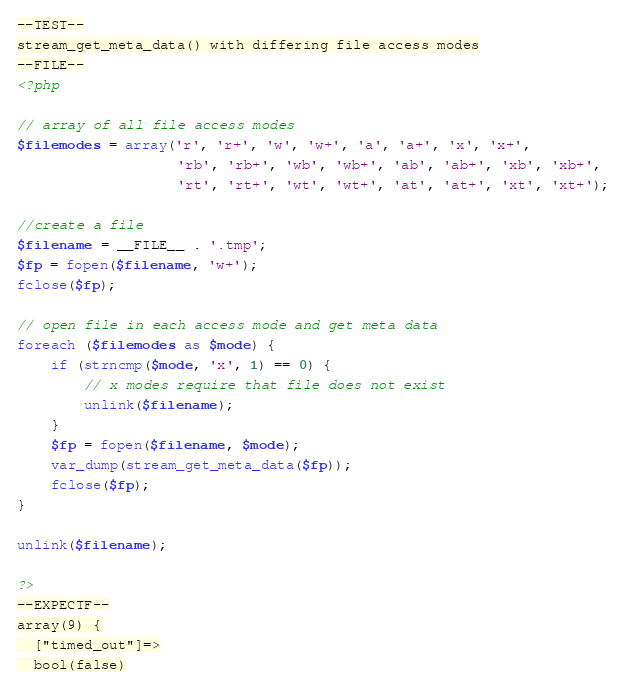<code> <loc_0><loc_0><loc_500><loc_500><_PHP_>--TEST--
stream_get_meta_data() with differing file access modes
--FILE--
<?php

// array of all file access modes
$filemodes = array('r', 'r+', 'w', 'w+', 'a', 'a+', 'x', 'x+',
                   'rb', 'rb+', 'wb', 'wb+', 'ab', 'ab+', 'xb', 'xb+',
                   'rt', 'rt+', 'wt', 'wt+', 'at', 'at+', 'xt', 'xt+');

//create a file
$filename = __FILE__ . '.tmp';
$fp = fopen($filename, 'w+');
fclose($fp);

// open file in each access mode and get meta data
foreach ($filemodes as $mode) {
	if (strncmp($mode, 'x', 1) == 0) {
		// x modes require that file does not exist
		unlink($filename);
	}
	$fp = fopen($filename, $mode);
	var_dump(stream_get_meta_data($fp));
	fclose($fp);
}

unlink($filename);

?>
--EXPECTF--
array(9) {
  ["timed_out"]=>
  bool(false)</code> 